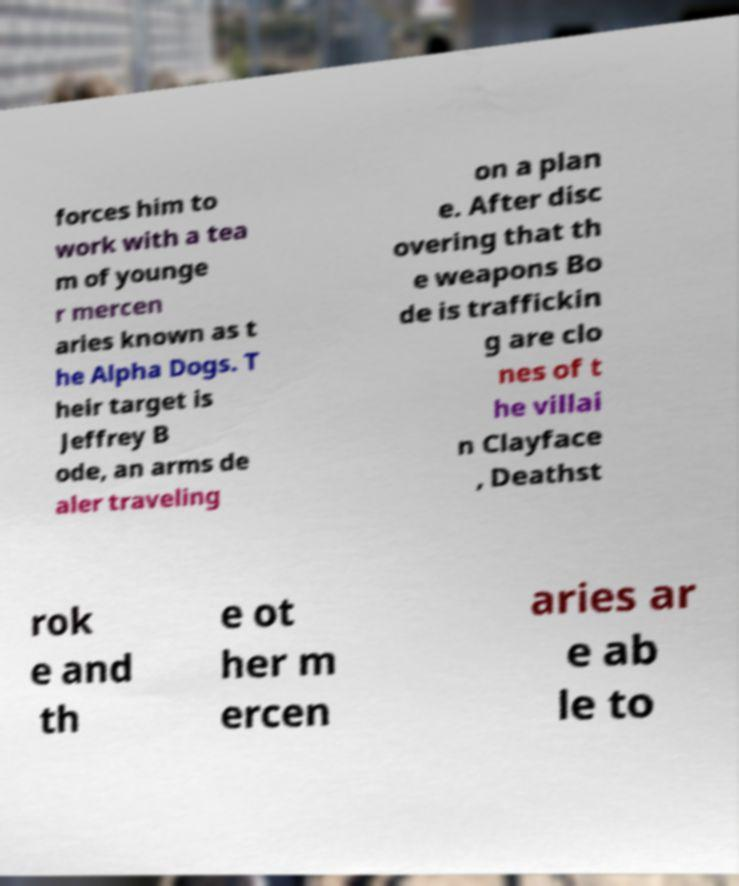Please read and relay the text visible in this image. What does it say? forces him to work with a tea m of younge r mercen aries known as t he Alpha Dogs. T heir target is Jeffrey B ode, an arms de aler traveling on a plan e. After disc overing that th e weapons Bo de is traffickin g are clo nes of t he villai n Clayface , Deathst rok e and th e ot her m ercen aries ar e ab le to 